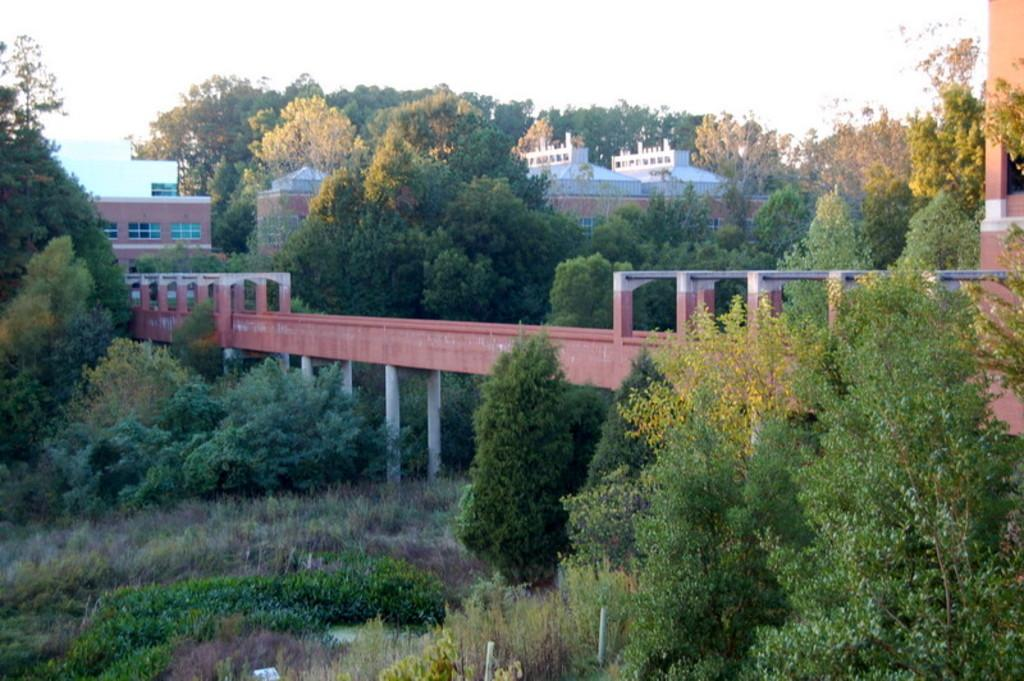What is the main structure in the center of the image? There is a bridge in the center of the image. What can be seen in the background of the image? There are trees and buildings in the background of the image. What is visible at the top of the image? The sky is visible at the top of the image. How many people are experiencing disgust in the image? There is no indication of anyone experiencing disgust in the image. What type of shop can be seen in the image? There is no shop present in the image. 